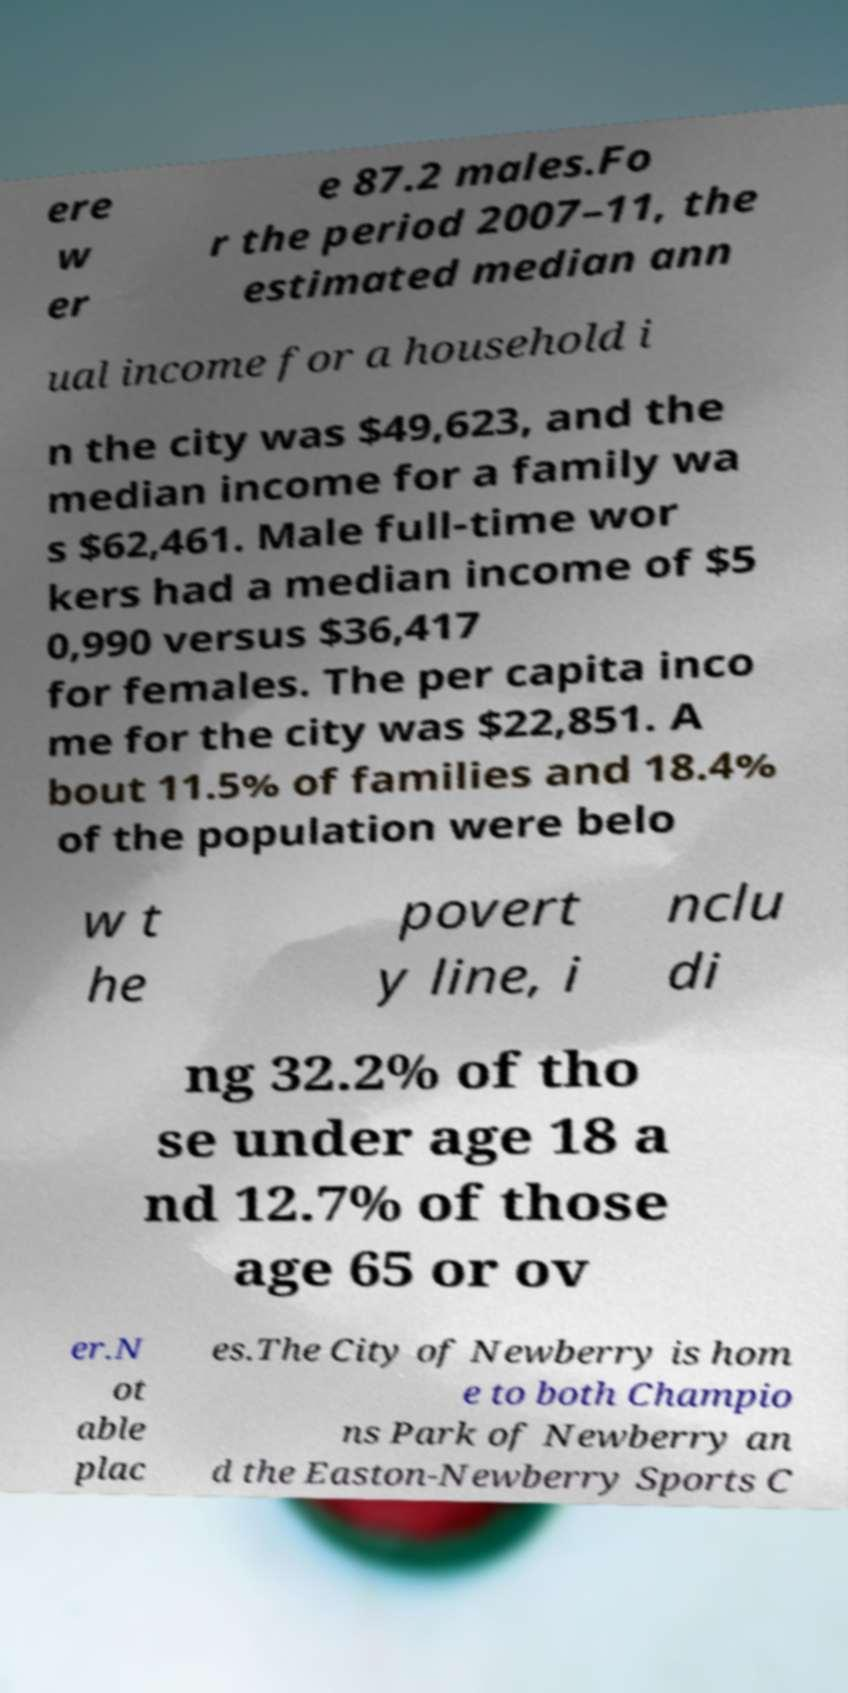Can you read and provide the text displayed in the image?This photo seems to have some interesting text. Can you extract and type it out for me? ere w er e 87.2 males.Fo r the period 2007–11, the estimated median ann ual income for a household i n the city was $49,623, and the median income for a family wa s $62,461. Male full-time wor kers had a median income of $5 0,990 versus $36,417 for females. The per capita inco me for the city was $22,851. A bout 11.5% of families and 18.4% of the population were belo w t he povert y line, i nclu di ng 32.2% of tho se under age 18 a nd 12.7% of those age 65 or ov er.N ot able plac es.The City of Newberry is hom e to both Champio ns Park of Newberry an d the Easton-Newberry Sports C 